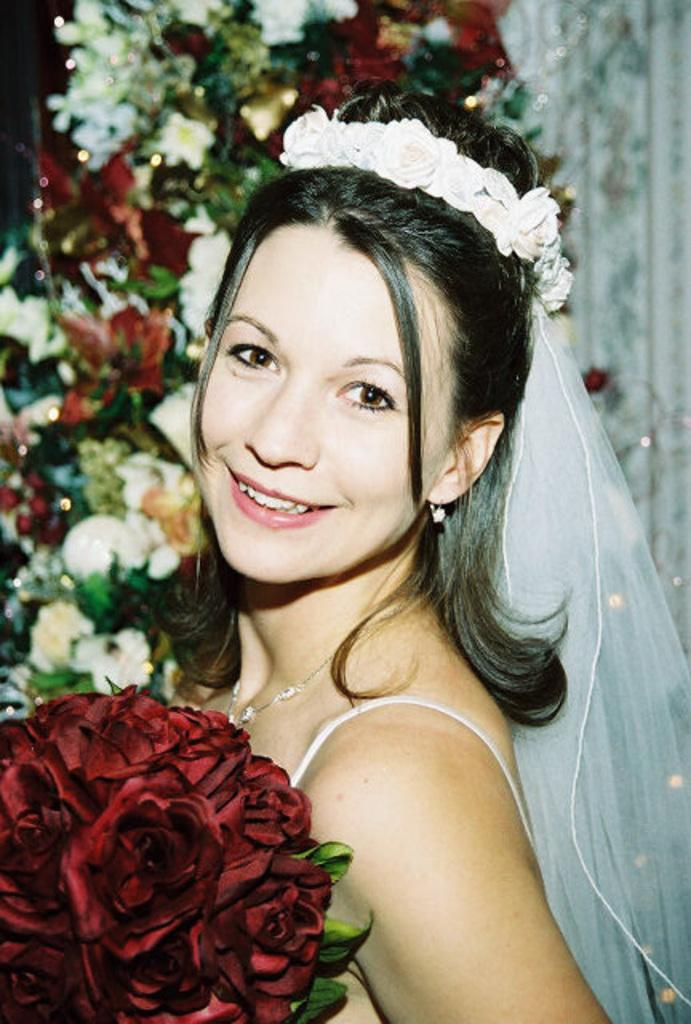Who is the main subject in the image? There is a woman in the image. What is the woman wearing? The woman is wearing a dress and headwear. What is the woman holding in the image? The woman is holding a flower bouquet. What is the woman's facial expression? The woman is smiling. How would you describe the background of the image? The background of the image is blurred. What can be seen in the blurred background? Flowers are visible in the blurred background. What type of quill is the woman using to write in the image? There is no quill present in the image, and the woman is not writing. How does the woman feel about her recent loss in the image? There is no indication of any loss or emotional state in the image. 